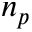<formula> <loc_0><loc_0><loc_500><loc_500>n _ { p }</formula> 